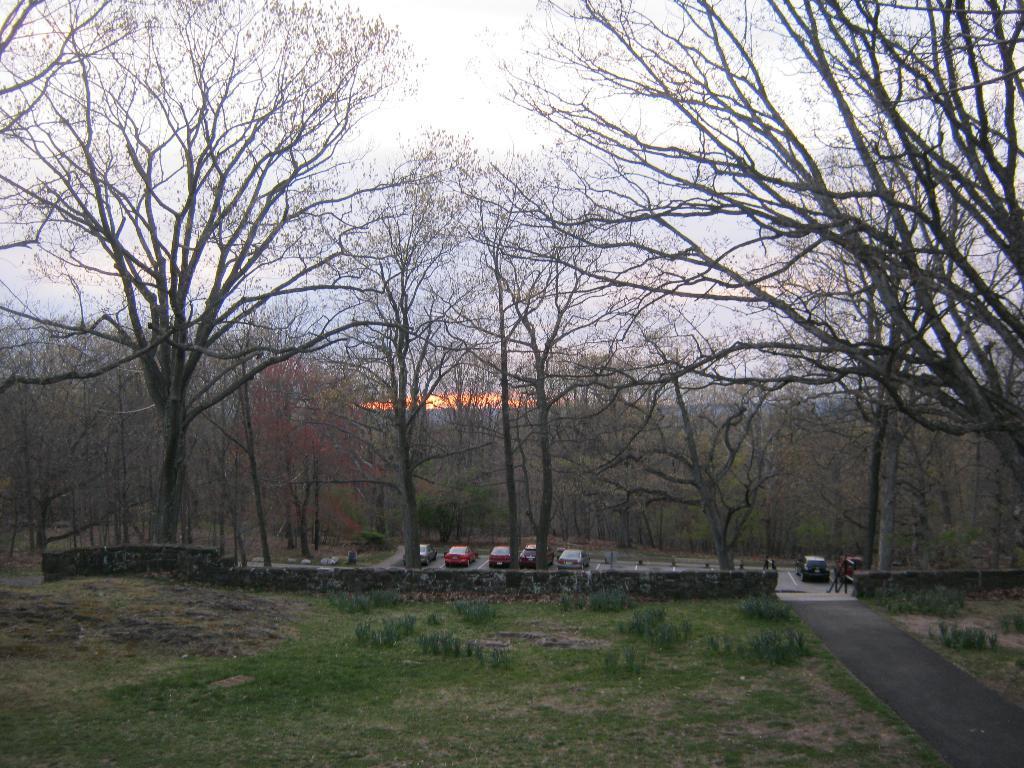Describe this image in one or two sentences. In this image we can see a few vehicles, on the road, there are some trees, grass, plants, also we can see the sky. 